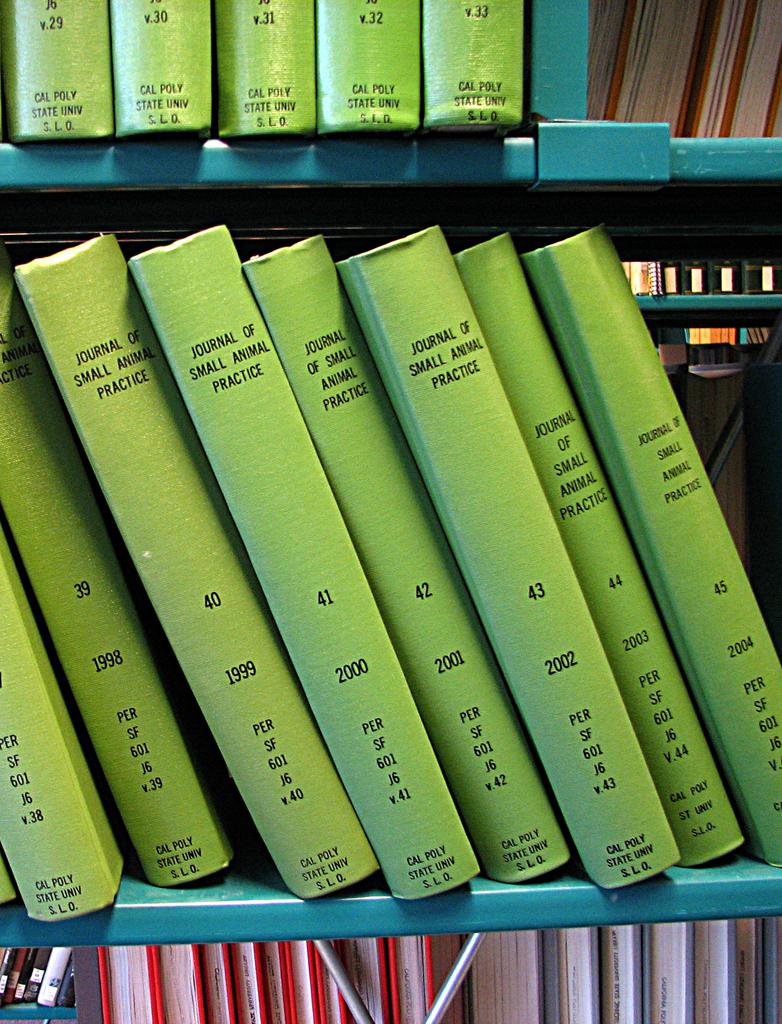What are these books?
Your answer should be very brief. Journal of small animal practice. When was book 45 wrote?
Offer a very short reply. 2004. 